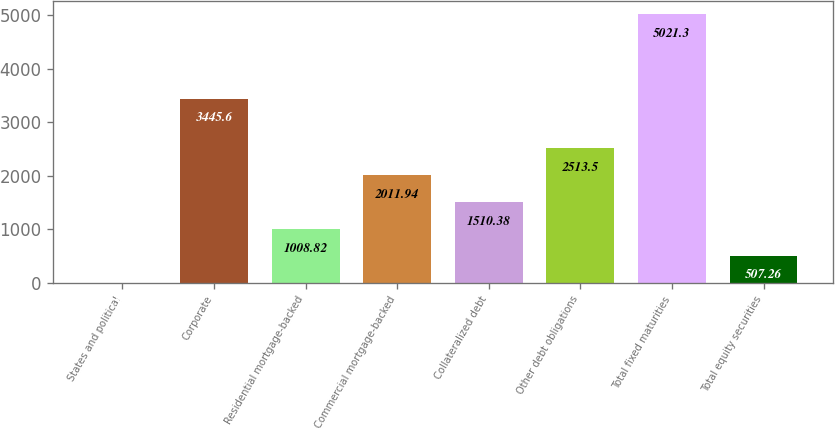<chart> <loc_0><loc_0><loc_500><loc_500><bar_chart><fcel>States and political<fcel>Corporate<fcel>Residential mortgage-backed<fcel>Commercial mortgage-backed<fcel>Collateralized debt<fcel>Other debt obligations<fcel>Total fixed maturities<fcel>Total equity securities<nl><fcel>5.7<fcel>3445.6<fcel>1008.82<fcel>2011.94<fcel>1510.38<fcel>2513.5<fcel>5021.3<fcel>507.26<nl></chart> 